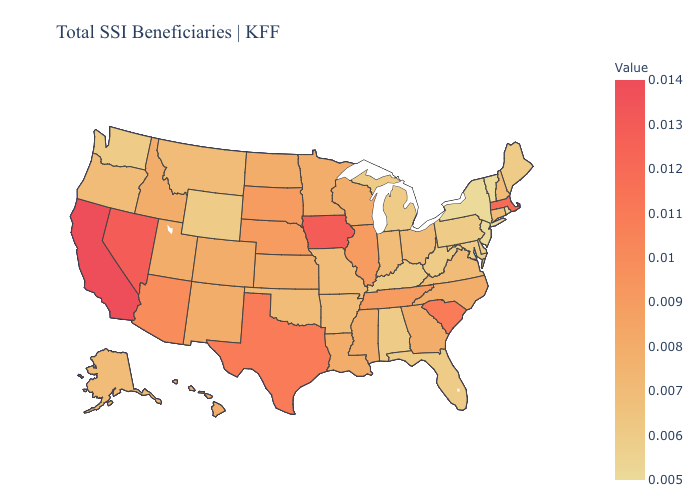Does New York have the lowest value in the USA?
Concise answer only. Yes. Does the map have missing data?
Write a very short answer. No. Among the states that border Indiana , does Ohio have the highest value?
Give a very brief answer. No. Among the states that border Alabama , which have the lowest value?
Quick response, please. Florida. Does Hawaii have the lowest value in the West?
Keep it brief. No. Which states have the highest value in the USA?
Quick response, please. California. 